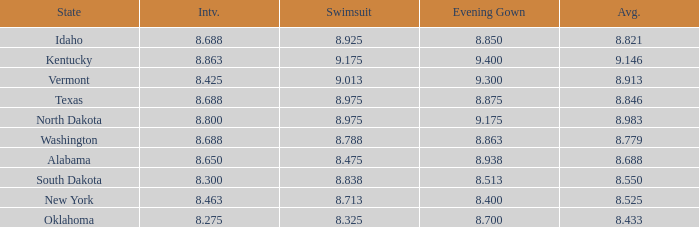What is the highest swimsuit score of the contestant with an evening gown larger than 9.175 and an interview score less than 8.425? None. 